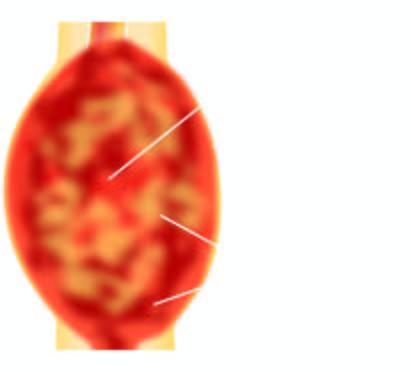what is largely extending into soft tissues including the skeletal muscle?
Answer the question using a single word or phrase. Tumour 